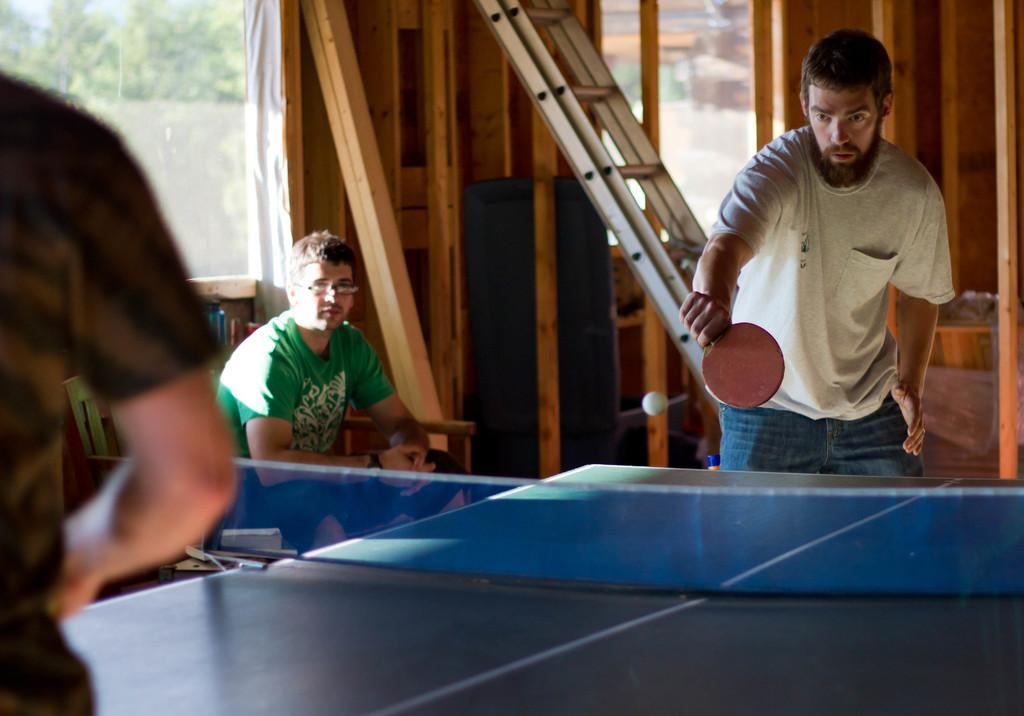In one or two sentences, can you explain what this image depicts? In this image there is a person with white t-shirt is holding red bat and playing table tennis and there is a person with green t-shirt is sitting. At the back there is a ladder and window. 